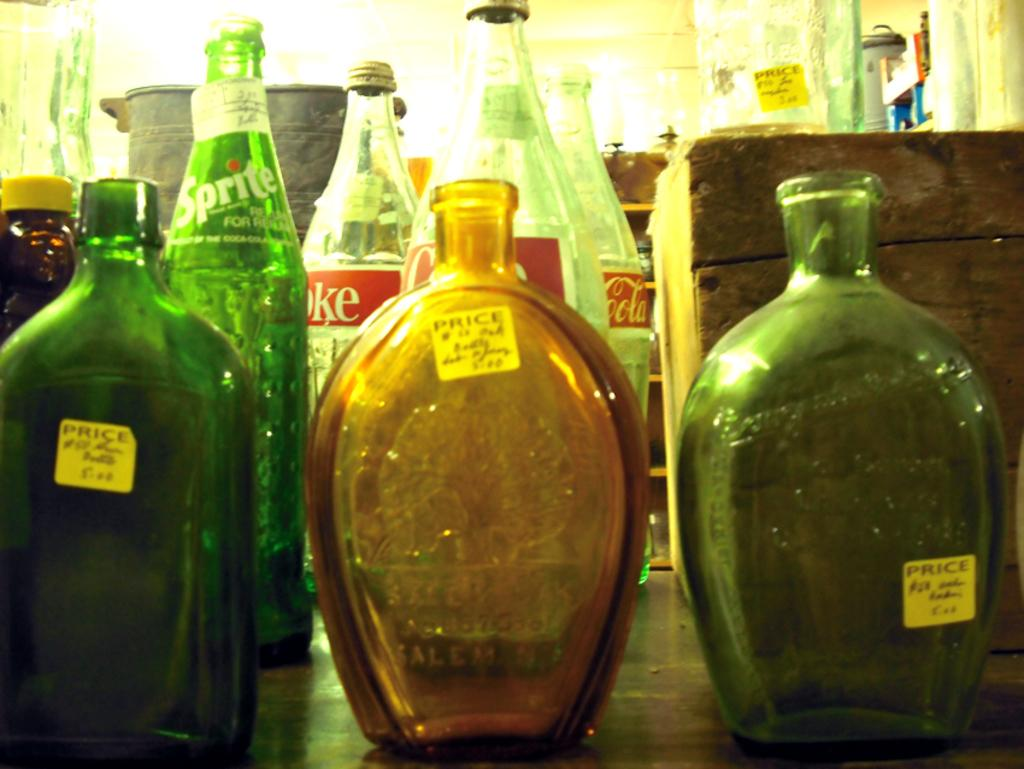<image>
Present a compact description of the photo's key features. Very old bottle are for sale with a yellow price tag on them. 